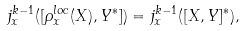Convert formula to latex. <formula><loc_0><loc_0><loc_500><loc_500>j ^ { k - 1 } _ { x } ( [ \rho ^ { l o c } _ { x } ( X ) , Y ^ { * } ] ) = j ^ { k - 1 } _ { x } ( [ X , Y ] ^ { * } ) ,</formula> 